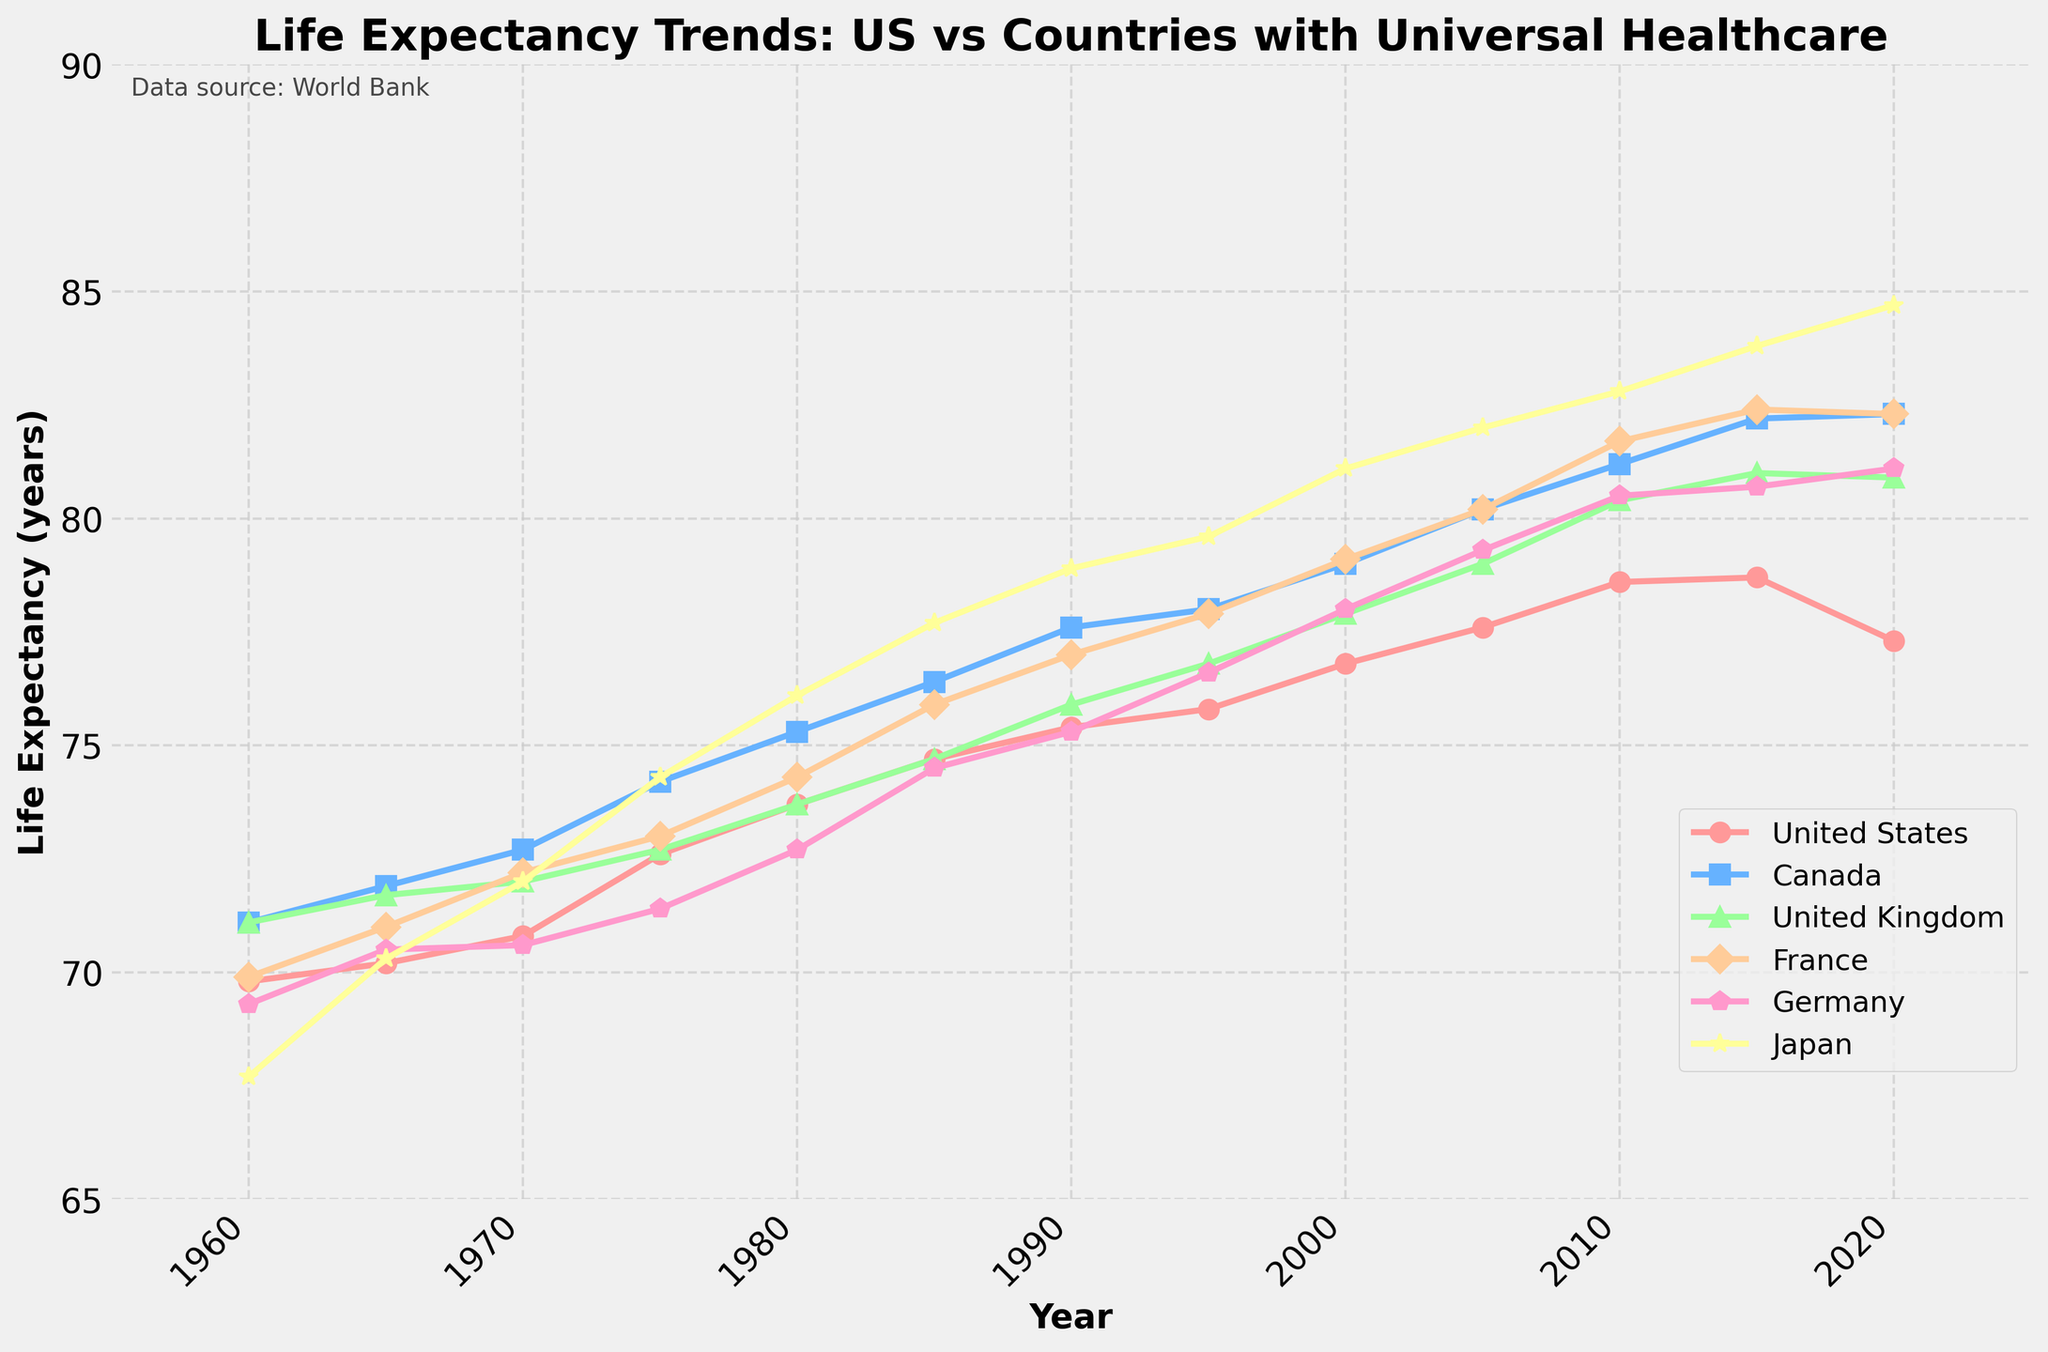When did Japan surpass the US in life expectancy? Observe the trend lines: Japan surpasses the US between 1965 and 1970.
Answer: Between 1965 and 1970 Which country had consistently higher life expectancy than the US since 1960? Compare US trends with others: Canada, UK, France, Germany, and Japan all consistently had higher life expectancy.
Answer: Canada, UK, France, Germany, Japan By how many years did Japan's life expectancy increase from 1960 to 2020? Subtract Japan's 1960 value from 2020: 84.7 - 67.7 = 17.
Answer: 17 Which country shows the steepest increase in life expectancy since 1960? Visually assess the slopes of lines for all countries; Japan’s line appears to have the steepest ascent.
Answer: Japan Which country had the highest life expectancy in 2020? Locate the highest end point in 2020: Japan at 84.7 years.
Answer: Japan What is the average life expectancy of Canada across all shown years? Sum all Canada values and divide by the number of years: (71.1 + 71.9 + 72.7 + 74.2 + 75.3 + 76.4 + 77.6 + 78.0 + 79.0 + 80.2 + 81.2 + 82.2 + 82.3) / 13 = 76.9.
Answer: 76.9 Which countries showed a decline in life expectancy from 2015 to 2020? Observe the trend: US life expectancy declined from 78.7 to 77.3; UK slightly from 81.0 to 80.9; France from 82.4 to 82.3.
Answer: US, UK, France Did any country have a life expectancy below 70 years after 1975? Check all data points post-1975; none fall below 70 years.
Answer: No What is the difference in life expectancy between the US and Germany in 2020? Subtract US value from Germany’s 2020 value: 81.1 - 77.3 = 3.8 years.
Answer: 3.8 years How does the life expectancy growth trend compare between US and France from 1960 to 2020? Both start around 70 years, but France shows a consistent and steeper increase, outweighing the US significantly towards 2020.
Answer: France grows faster than the US 